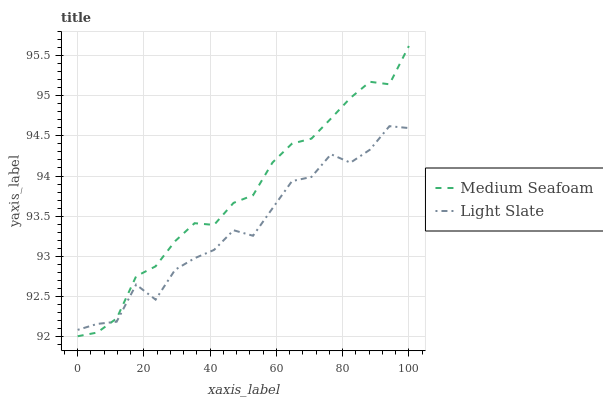Does Light Slate have the minimum area under the curve?
Answer yes or no. Yes. Does Medium Seafoam have the maximum area under the curve?
Answer yes or no. Yes. Does Medium Seafoam have the minimum area under the curve?
Answer yes or no. No. Is Medium Seafoam the smoothest?
Answer yes or no. Yes. Is Light Slate the roughest?
Answer yes or no. Yes. Is Medium Seafoam the roughest?
Answer yes or no. No. Does Medium Seafoam have the lowest value?
Answer yes or no. Yes. Does Medium Seafoam have the highest value?
Answer yes or no. Yes. Does Light Slate intersect Medium Seafoam?
Answer yes or no. Yes. Is Light Slate less than Medium Seafoam?
Answer yes or no. No. Is Light Slate greater than Medium Seafoam?
Answer yes or no. No. 